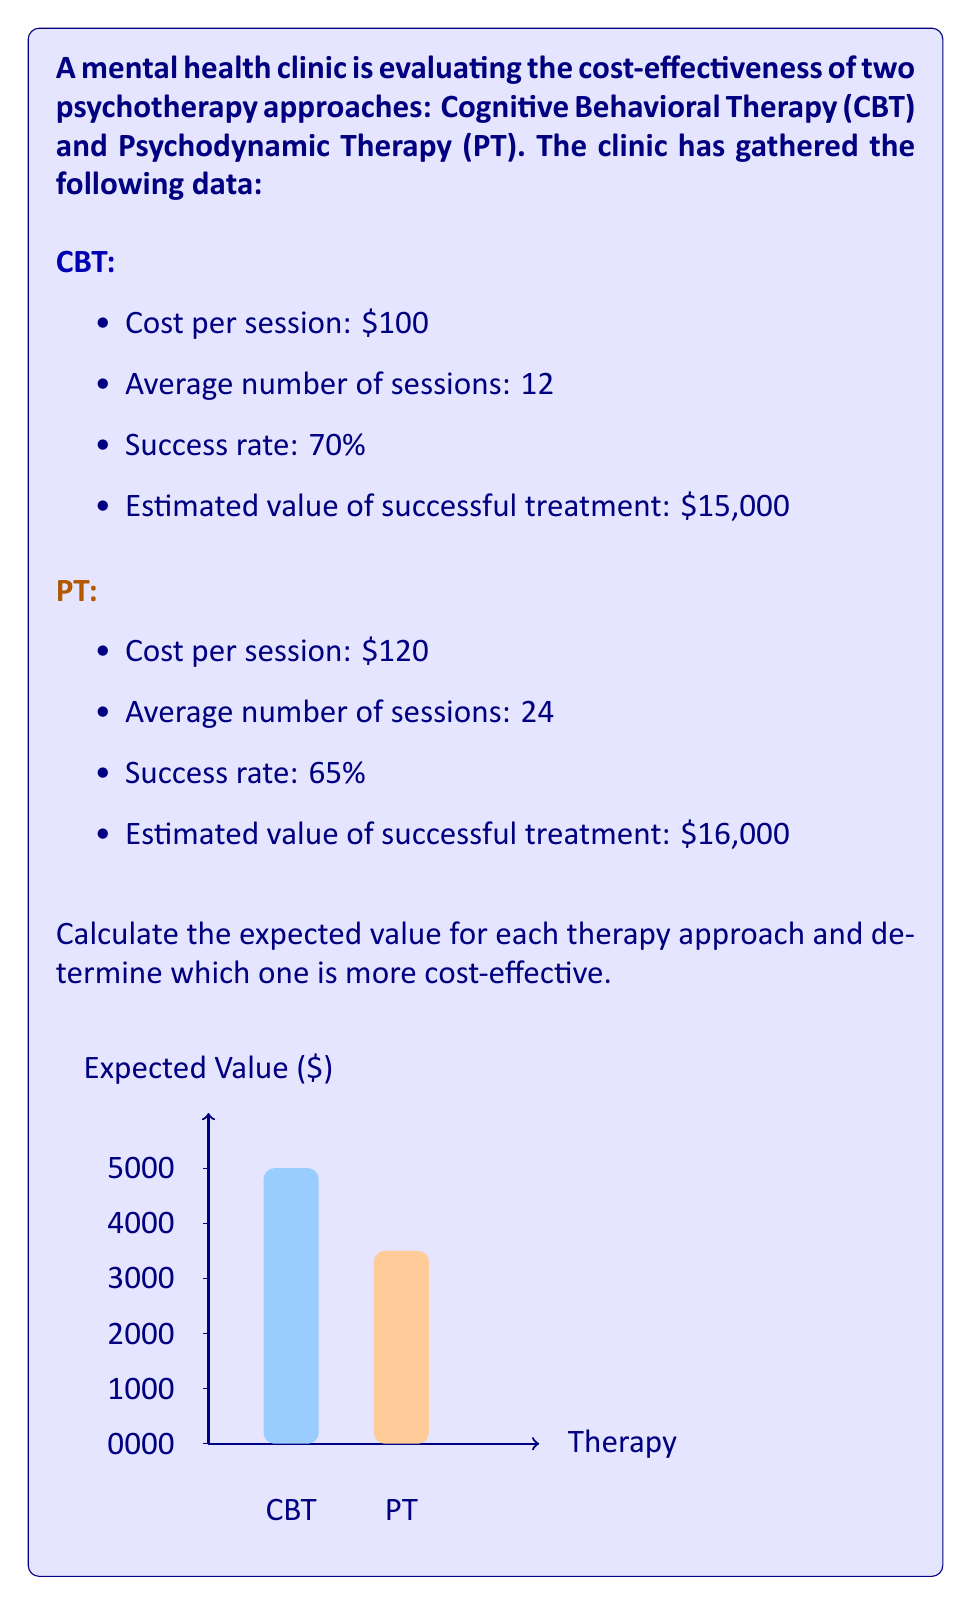Can you answer this question? To calculate the expected value for each therapy approach, we'll use the formula:

$$\text{Expected Value} = (\text{Success Rate} \times \text{Value of Success}) - \text{Total Cost}$$

For Cognitive Behavioral Therapy (CBT):

1. Calculate the total cost:
   $$\text{Total Cost}_{\text{CBT}} = \$100 \times 12 = \$1,200$$

2. Calculate the expected value:
   $$\begin{align*}
   \text{EV}_{\text{CBT}} &= (0.70 \times \$15,000) - \$1,200 \\
   &= \$10,500 - \$1,200 \\
   &= \$9,300
   \end{align*}$$

For Psychodynamic Therapy (PT):

1. Calculate the total cost:
   $$\text{Total Cost}_{\text{PT}} = \$120 \times 24 = \$2,880$$

2. Calculate the expected value:
   $$\begin{align*}
   \text{EV}_{\text{PT}} &= (0.65 \times \$16,000) - \$2,880 \\
   &= \$10,400 - \$2,880 \\
   &= \$7,520
   \end{align*}$$

Comparing the two approaches:
- CBT has an expected value of $9,300
- PT has an expected value of $7,520

Therefore, Cognitive Behavioral Therapy (CBT) is more cost-effective in this scenario.
Answer: CBT is more cost-effective with an expected value of $9,300 compared to PT's $7,520. 